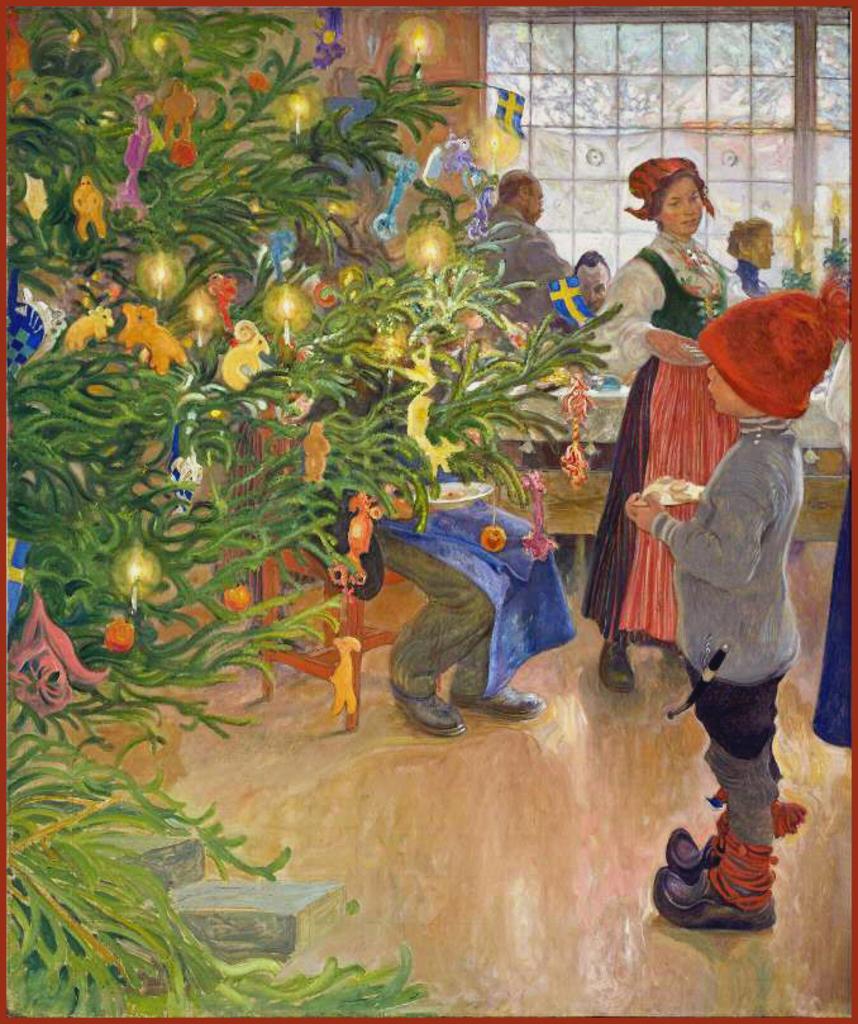In one or two sentences, can you explain what this image depicts? This image is a painting in this painting. In this painting we can see people standing and some of them are sitting. There are tables. On the left there is a decor. In the background we can see a window and a wall. 